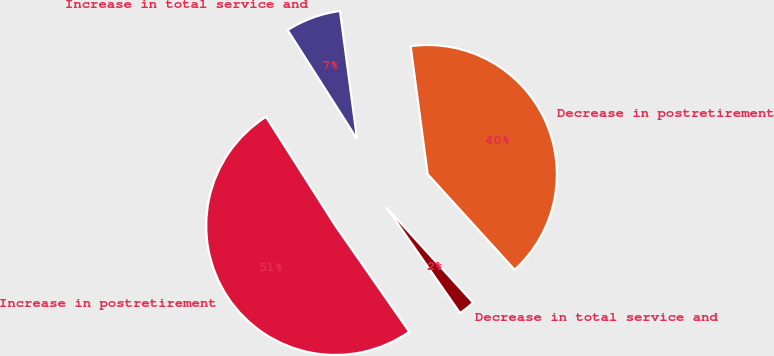Convert chart. <chart><loc_0><loc_0><loc_500><loc_500><pie_chart><fcel>Increase in total service and<fcel>Increase in postretirement<fcel>Decrease in total service and<fcel>Decrease in postretirement<nl><fcel>6.92%<fcel>50.66%<fcel>2.06%<fcel>40.36%<nl></chart> 